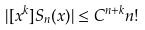Convert formula to latex. <formula><loc_0><loc_0><loc_500><loc_500>| [ x ^ { k } ] S _ { n } ( x ) | \leq C ^ { n + k } n !</formula> 